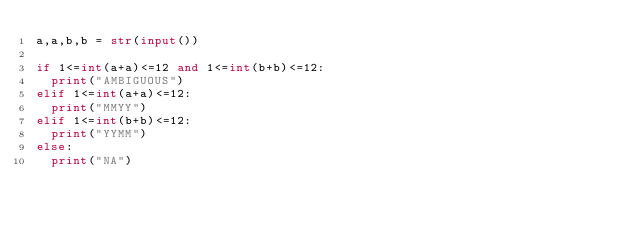<code> <loc_0><loc_0><loc_500><loc_500><_Python_>a,a,b,b = str(input())

if 1<=int(a+a)<=12 and 1<=int(b+b)<=12:
  print("AMBIGUOUS")
elif 1<=int(a+a)<=12:
  print("MMYY")
elif 1<=int(b+b)<=12:
  print("YYMM")
else:
  print("NA")
</code> 